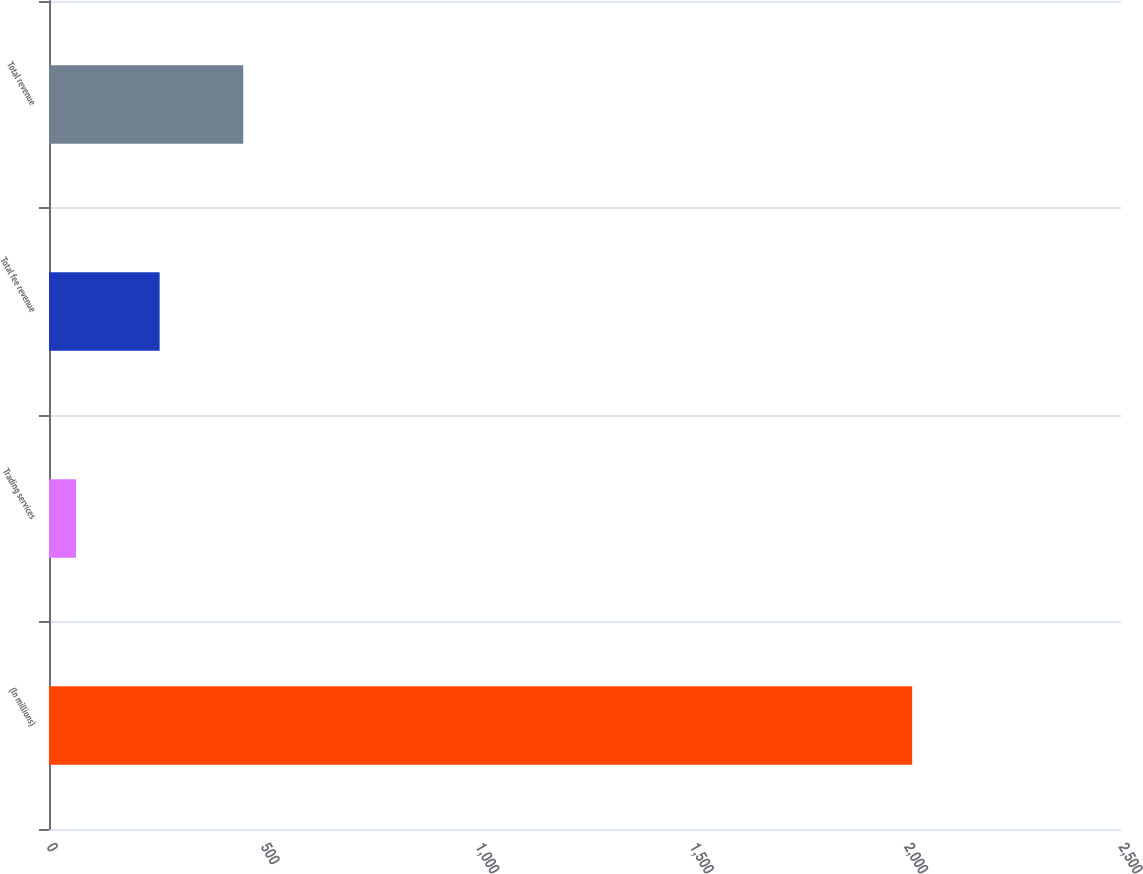Convert chart to OTSL. <chart><loc_0><loc_0><loc_500><loc_500><bar_chart><fcel>(In millions)<fcel>Trading services<fcel>Total fee revenue<fcel>Total revenue<nl><fcel>2013<fcel>63<fcel>258<fcel>453<nl></chart> 